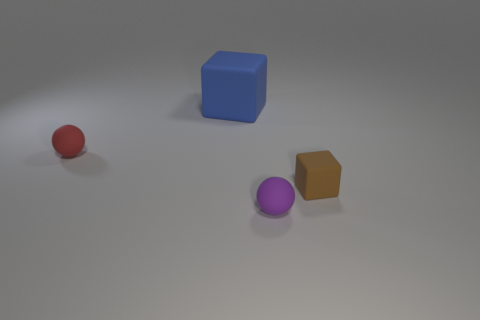Add 3 purple matte objects. How many objects exist? 7 Subtract all red spheres. How many spheres are left? 1 Subtract all brown blocks. Subtract all blue spheres. How many blocks are left? 1 Subtract all tiny purple objects. Subtract all blue objects. How many objects are left? 2 Add 1 small red rubber spheres. How many small red rubber spheres are left? 2 Add 3 large cyan cylinders. How many large cyan cylinders exist? 3 Subtract 0 red cubes. How many objects are left? 4 